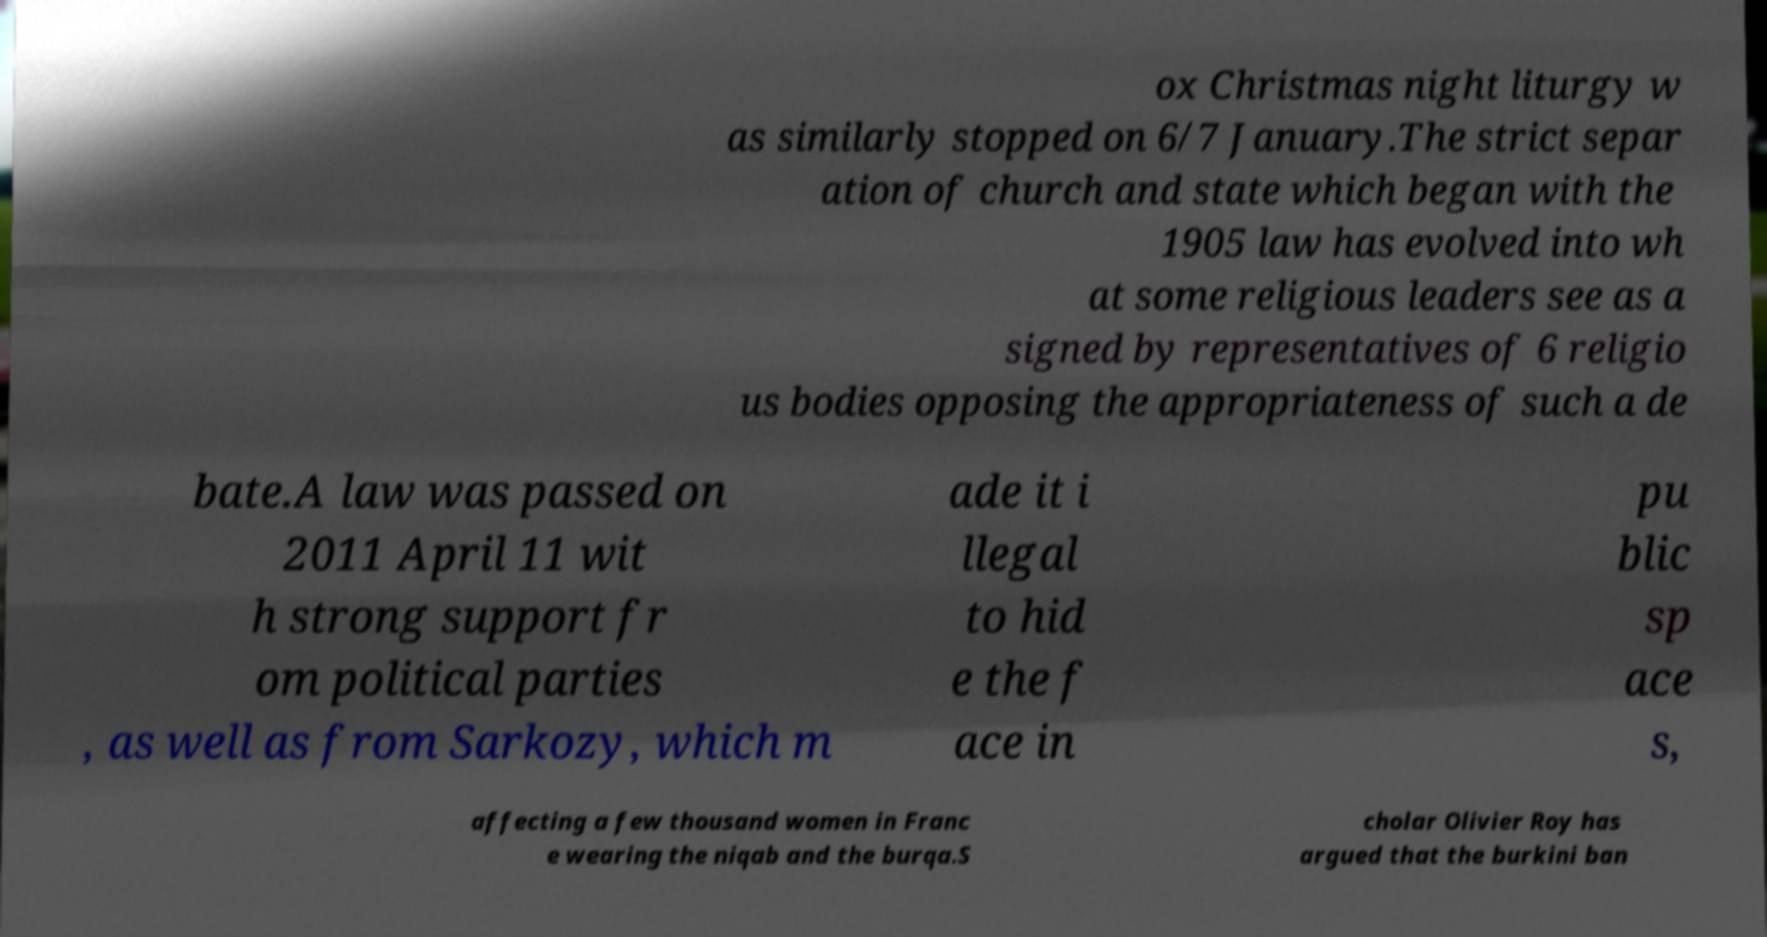Can you accurately transcribe the text from the provided image for me? ox Christmas night liturgy w as similarly stopped on 6/7 January.The strict separ ation of church and state which began with the 1905 law has evolved into wh at some religious leaders see as a signed by representatives of 6 religio us bodies opposing the appropriateness of such a de bate.A law was passed on 2011 April 11 wit h strong support fr om political parties , as well as from Sarkozy, which m ade it i llegal to hid e the f ace in pu blic sp ace s, affecting a few thousand women in Franc e wearing the niqab and the burqa.S cholar Olivier Roy has argued that the burkini ban 